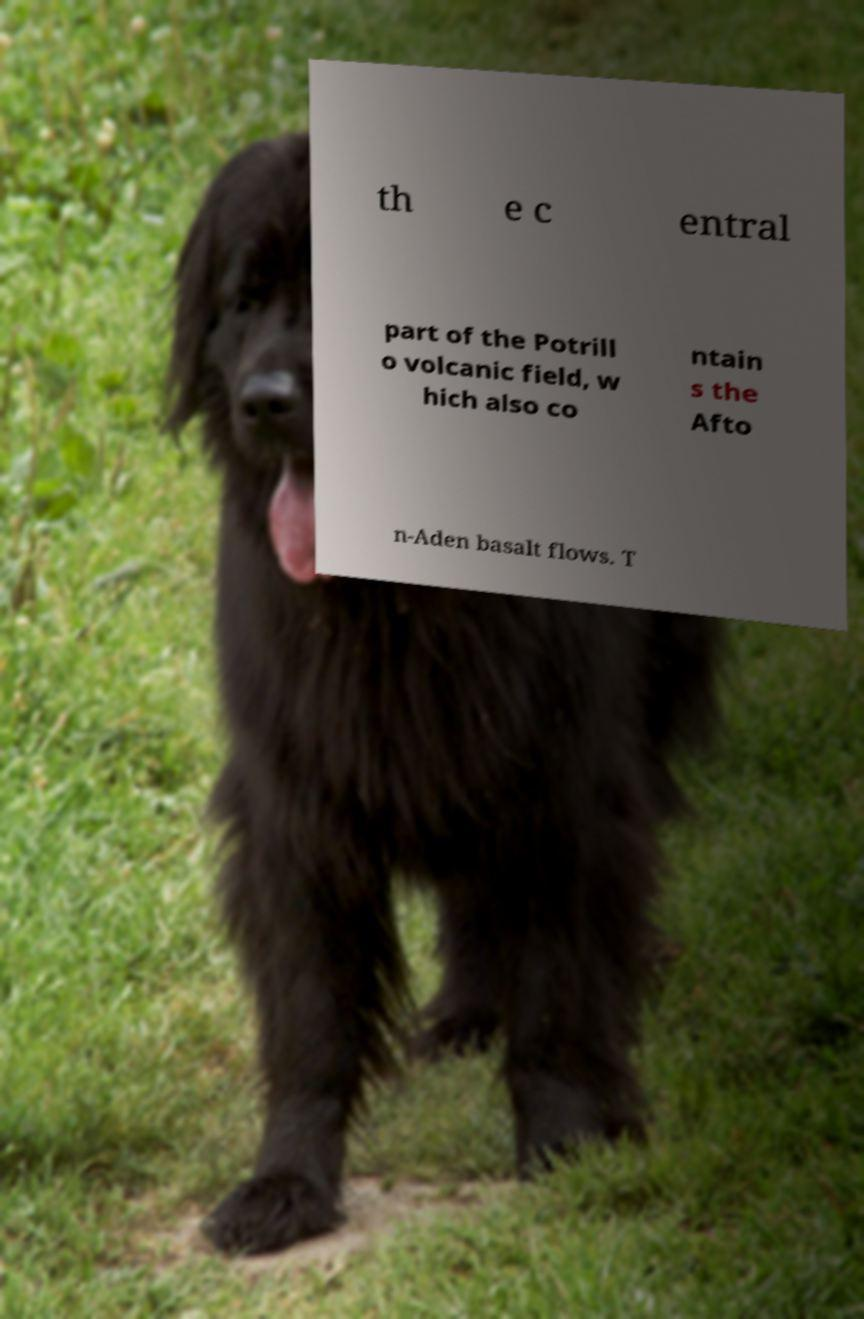Can you read and provide the text displayed in the image?This photo seems to have some interesting text. Can you extract and type it out for me? th e c entral part of the Potrill o volcanic field, w hich also co ntain s the Afto n-Aden basalt flows. T 